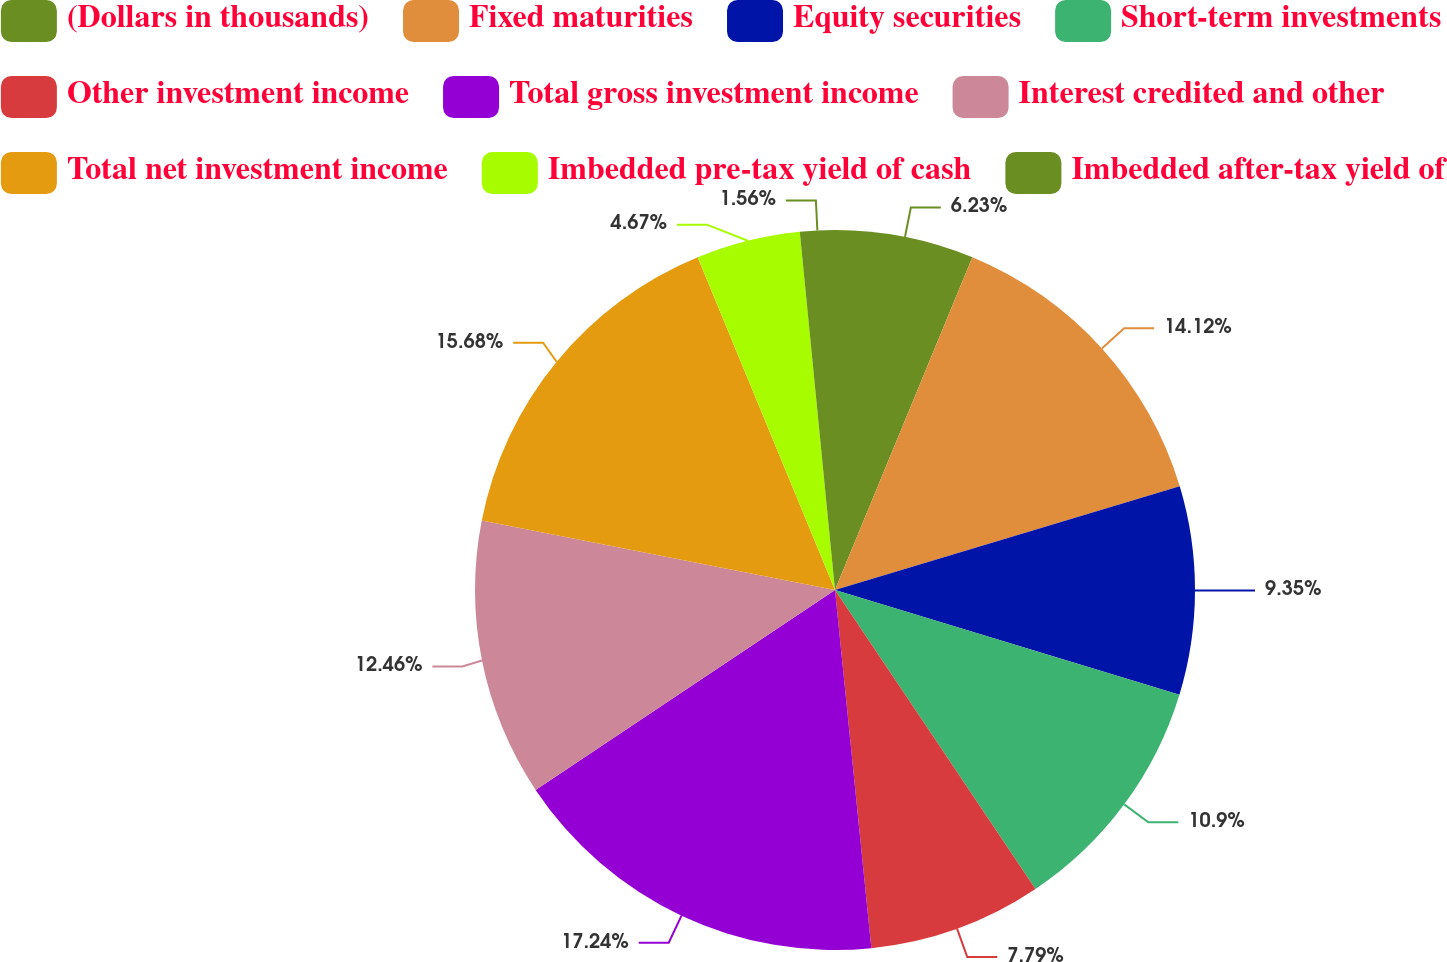Convert chart to OTSL. <chart><loc_0><loc_0><loc_500><loc_500><pie_chart><fcel>(Dollars in thousands)<fcel>Fixed maturities<fcel>Equity securities<fcel>Short-term investments<fcel>Other investment income<fcel>Total gross investment income<fcel>Interest credited and other<fcel>Total net investment income<fcel>Imbedded pre-tax yield of cash<fcel>Imbedded after-tax yield of<nl><fcel>6.23%<fcel>14.12%<fcel>9.35%<fcel>10.9%<fcel>7.79%<fcel>17.24%<fcel>12.46%<fcel>15.68%<fcel>4.67%<fcel>1.56%<nl></chart> 